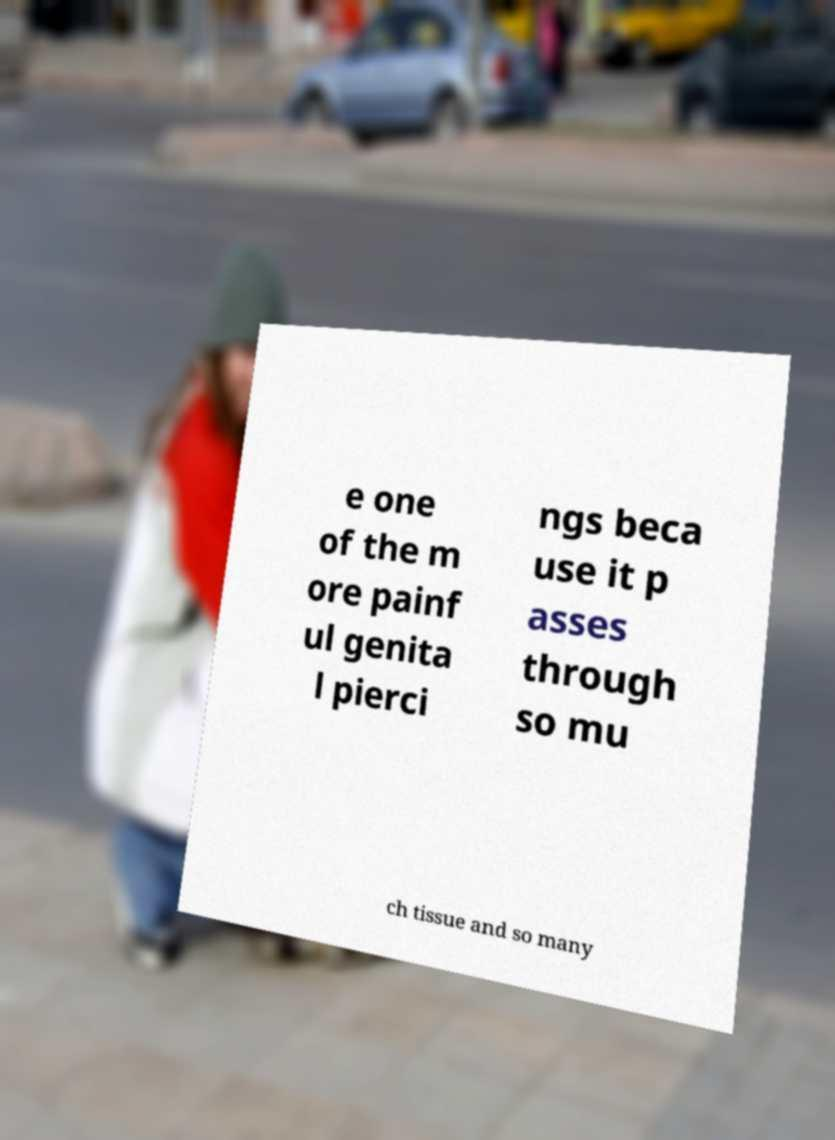Could you extract and type out the text from this image? e one of the m ore painf ul genita l pierci ngs beca use it p asses through so mu ch tissue and so many 